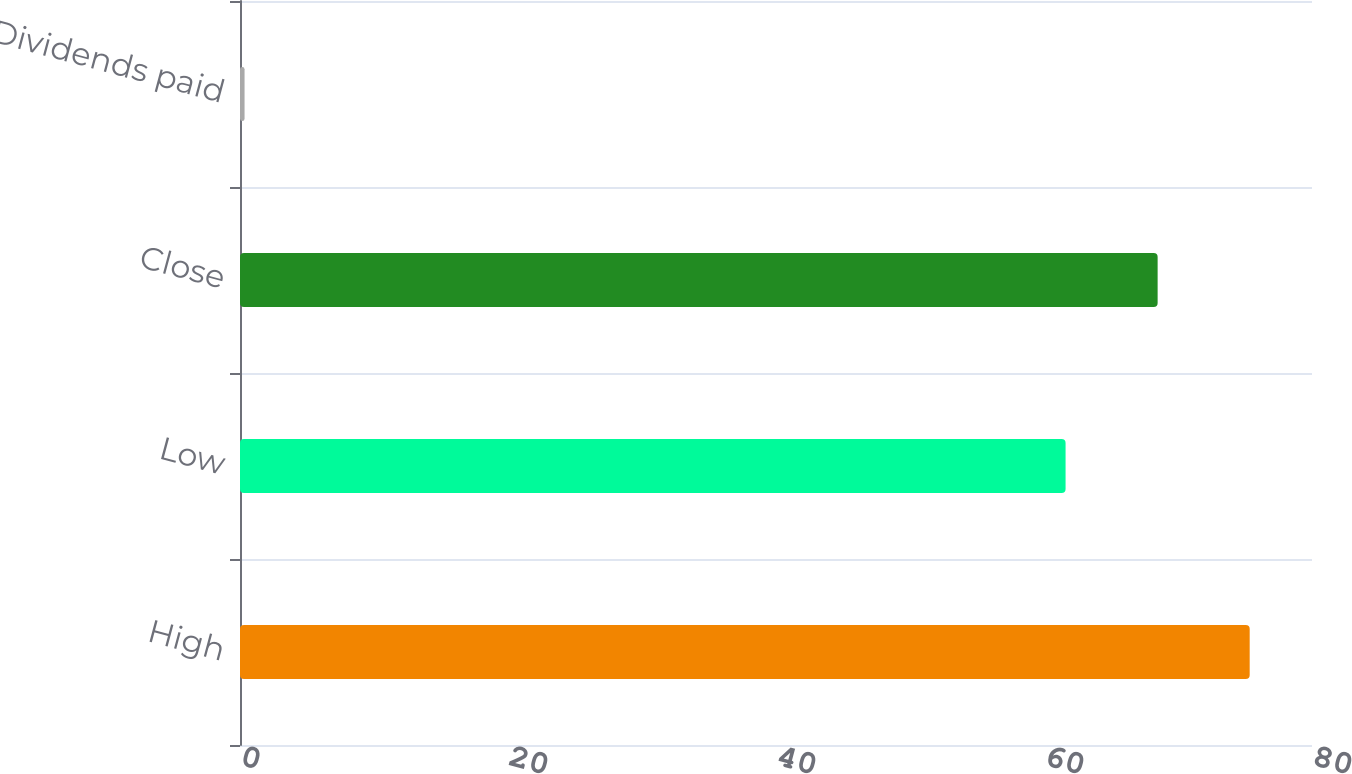Convert chart to OTSL. <chart><loc_0><loc_0><loc_500><loc_500><bar_chart><fcel>High<fcel>Low<fcel>Close<fcel>Dividends paid<nl><fcel>75.35<fcel>61.61<fcel>68.48<fcel>0.34<nl></chart> 